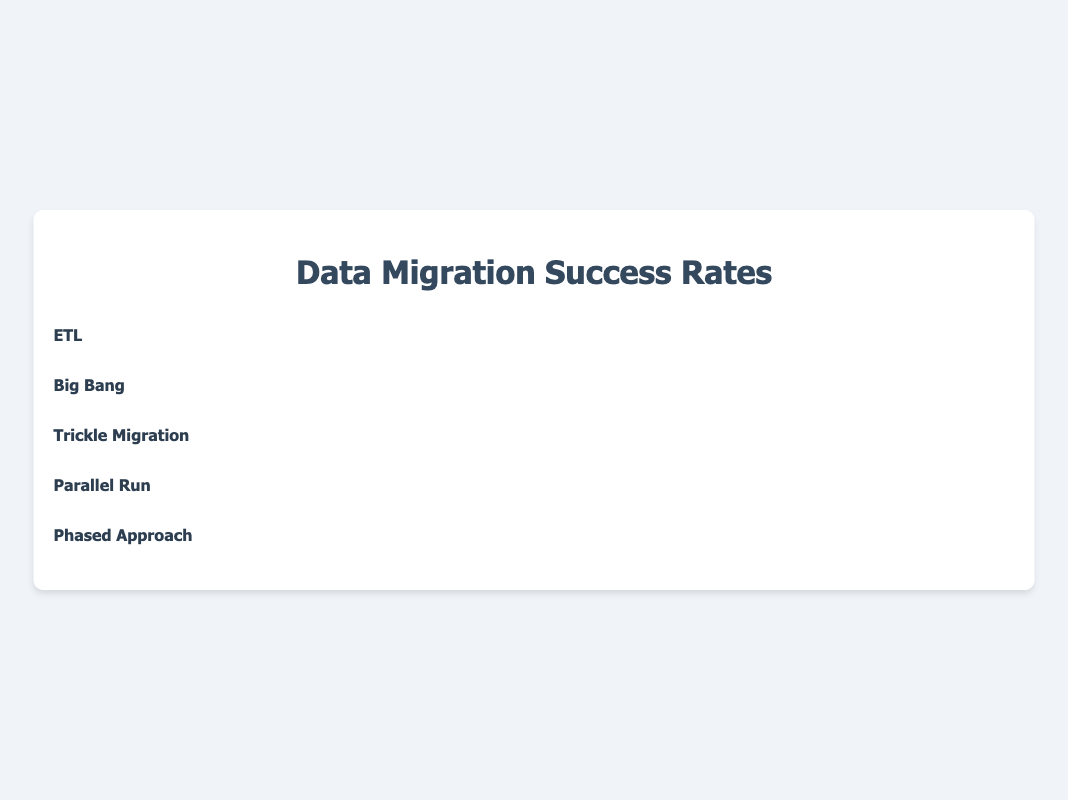What is the success rate of the ETL methodology? Look at the success rate indicated next to the ETL methodology.
Answer: 75% Which methodology has the highest success rate? Identify the methodology with the highest percentage next to its label.
Answer: Phased Approach What is the difference in success rates between the Big Bang and Trickle Migration methodologies? Subtract the success rate of Big Bang from the success rate of Trickle Migration: 85% - 60% = 25%
Answer: 25% How many icons represent the success rate of the Parallel Run methodology? Count the icons next to the Parallel Run label. Each icon represents a 10% rate.
Answer: 8 Which methodologies have success rates greater than 80%? Identify methodologies with success rates higher than 80%: Trickle Migration (85%), Phased Approach (90%)
Answer: Trickle Migration, Phased Approach What is the average success rate across all methodologies? Sum all success rates and divide by the number of methodologies: (75% + 60% + 85% + 80% + 90%) / 5 = 78%
Answer: 78% List the icon types used for each methodology. Identify and list the icon types beside each methodology’s name.
Answer: ETL: 🗄️, Big Bang: 🚀, Trickle Migration: 🚰, Parallel Run: ∥, Phased Approach: 🪜 How does the success rate of Parallel Run compare to ETL? Compare the success rates of Parallel Run (80%) and ETL (75%).
Answer: Parallel Run has a 5% higher success rate than ETL What is the combined success rate of the ETL and Big Bang methodologies? Add the success rates of ETL and Big Bang: 75% + 60% = 135%
Answer: 135% Which methodology has the lowest success rate? Identify the methodology with the lowest percentage next to its label.
Answer: Big Bang 